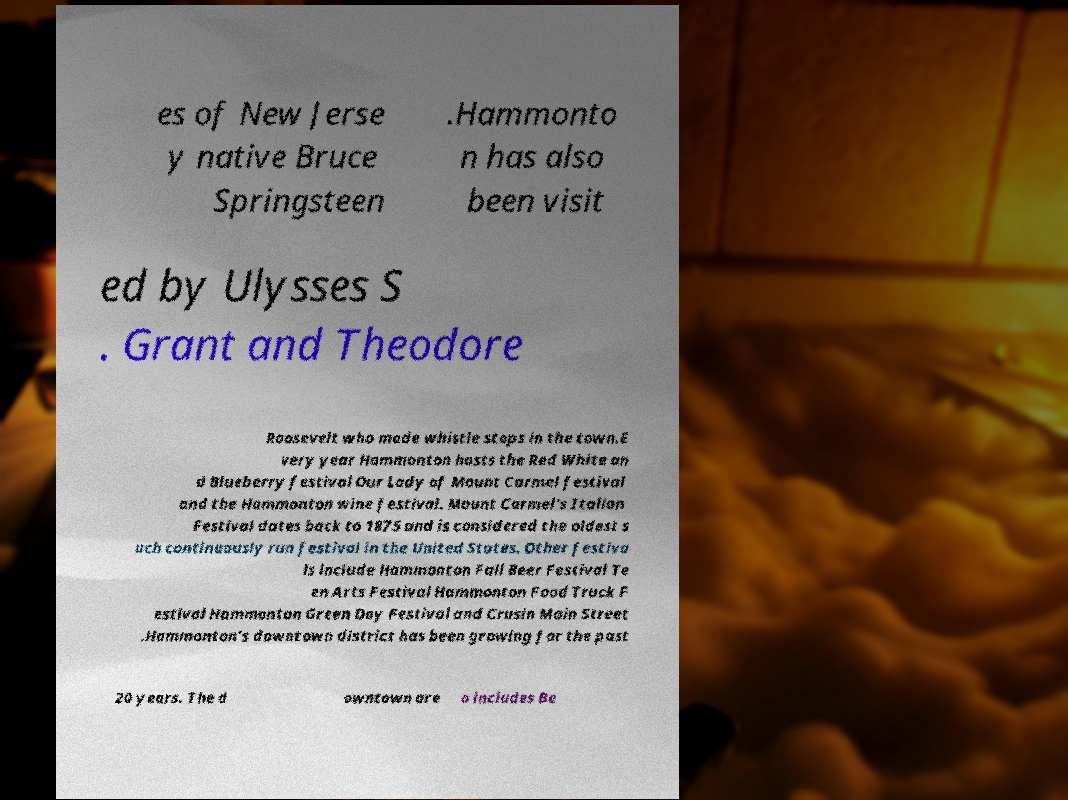Can you accurately transcribe the text from the provided image for me? es of New Jerse y native Bruce Springsteen .Hammonto n has also been visit ed by Ulysses S . Grant and Theodore Roosevelt who made whistle stops in the town.E very year Hammonton hosts the Red White an d Blueberry festival Our Lady of Mount Carmel festival and the Hammonton wine festival. Mount Carmel's Italian Festival dates back to 1875 and is considered the oldest s uch continuously run festival in the United States. Other festiva ls include Hammonton Fall Beer Festival Te en Arts Festival Hammonton Food Truck F estival Hammonton Green Day Festival and Crusin Main Street .Hammonton's downtown district has been growing for the past 20 years. The d owntown are a includes Be 